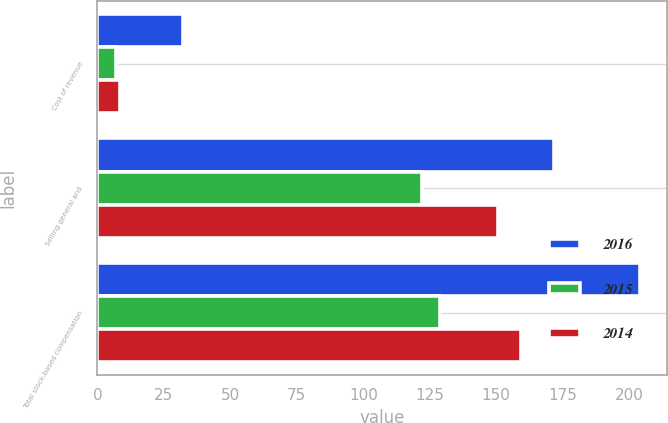Convert chart to OTSL. <chart><loc_0><loc_0><loc_500><loc_500><stacked_bar_chart><ecel><fcel>Cost of revenue<fcel>Selling general and<fcel>Total stock-based compensation<nl><fcel>2016<fcel>32.2<fcel>171.7<fcel>203.9<nl><fcel>2015<fcel>6.9<fcel>122<fcel>128.9<nl><fcel>2014<fcel>8.5<fcel>150.8<fcel>159.3<nl></chart> 